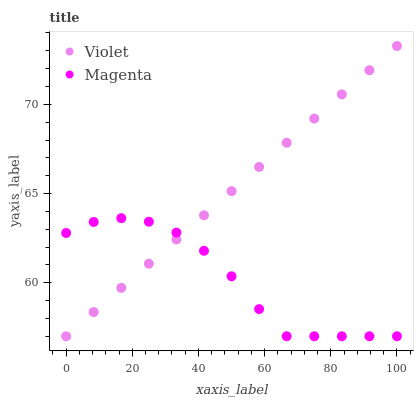Does Magenta have the minimum area under the curve?
Answer yes or no. Yes. Does Violet have the maximum area under the curve?
Answer yes or no. Yes. Does Violet have the minimum area under the curve?
Answer yes or no. No. Is Violet the smoothest?
Answer yes or no. Yes. Is Magenta the roughest?
Answer yes or no. Yes. Is Violet the roughest?
Answer yes or no. No. Does Magenta have the lowest value?
Answer yes or no. Yes. Does Violet have the highest value?
Answer yes or no. Yes. Does Violet intersect Magenta?
Answer yes or no. Yes. Is Violet less than Magenta?
Answer yes or no. No. Is Violet greater than Magenta?
Answer yes or no. No. 